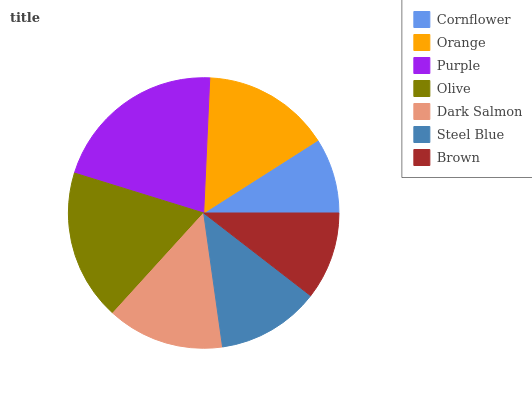Is Cornflower the minimum?
Answer yes or no. Yes. Is Purple the maximum?
Answer yes or no. Yes. Is Orange the minimum?
Answer yes or no. No. Is Orange the maximum?
Answer yes or no. No. Is Orange greater than Cornflower?
Answer yes or no. Yes. Is Cornflower less than Orange?
Answer yes or no. Yes. Is Cornflower greater than Orange?
Answer yes or no. No. Is Orange less than Cornflower?
Answer yes or no. No. Is Dark Salmon the high median?
Answer yes or no. Yes. Is Dark Salmon the low median?
Answer yes or no. Yes. Is Purple the high median?
Answer yes or no. No. Is Orange the low median?
Answer yes or no. No. 